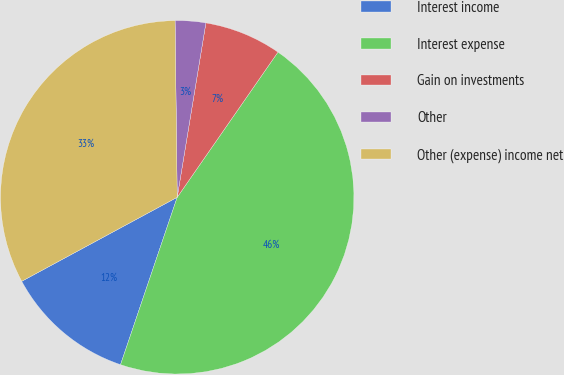Convert chart. <chart><loc_0><loc_0><loc_500><loc_500><pie_chart><fcel>Interest income<fcel>Interest expense<fcel>Gain on investments<fcel>Other<fcel>Other (expense) income net<nl><fcel>11.92%<fcel>45.54%<fcel>7.06%<fcel>2.79%<fcel>32.69%<nl></chart> 